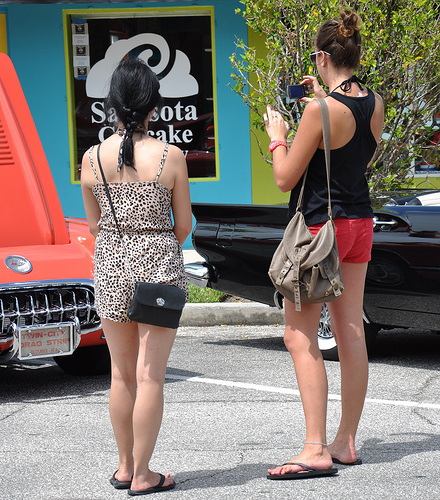<image>
Is there a bag on the woman? No. The bag is not positioned on the woman. They may be near each other, but the bag is not supported by or resting on top of the woman. Is there a car to the right of the woman? Yes. From this viewpoint, the car is positioned to the right side relative to the woman. 